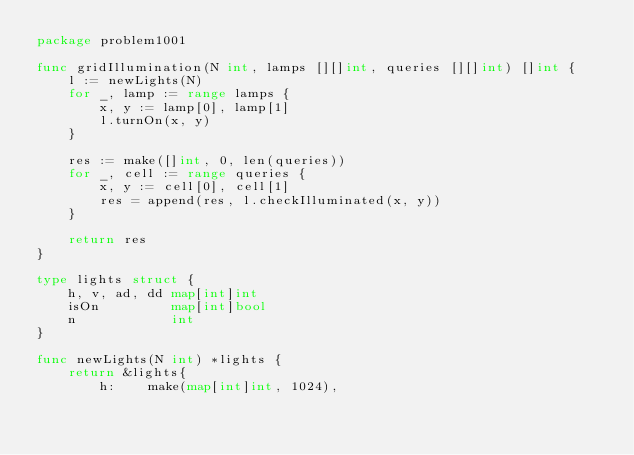Convert code to text. <code><loc_0><loc_0><loc_500><loc_500><_Go_>package problem1001

func gridIllumination(N int, lamps [][]int, queries [][]int) []int {
	l := newLights(N)
	for _, lamp := range lamps {
		x, y := lamp[0], lamp[1]
		l.turnOn(x, y)
	}

	res := make([]int, 0, len(queries))
	for _, cell := range queries {
		x, y := cell[0], cell[1]
		res = append(res, l.checkIlluminated(x, y))
	}

	return res
}

type lights struct {
	h, v, ad, dd map[int]int
	isOn         map[int]bool
	n            int
}

func newLights(N int) *lights {
	return &lights{
		h:    make(map[int]int, 1024),</code> 